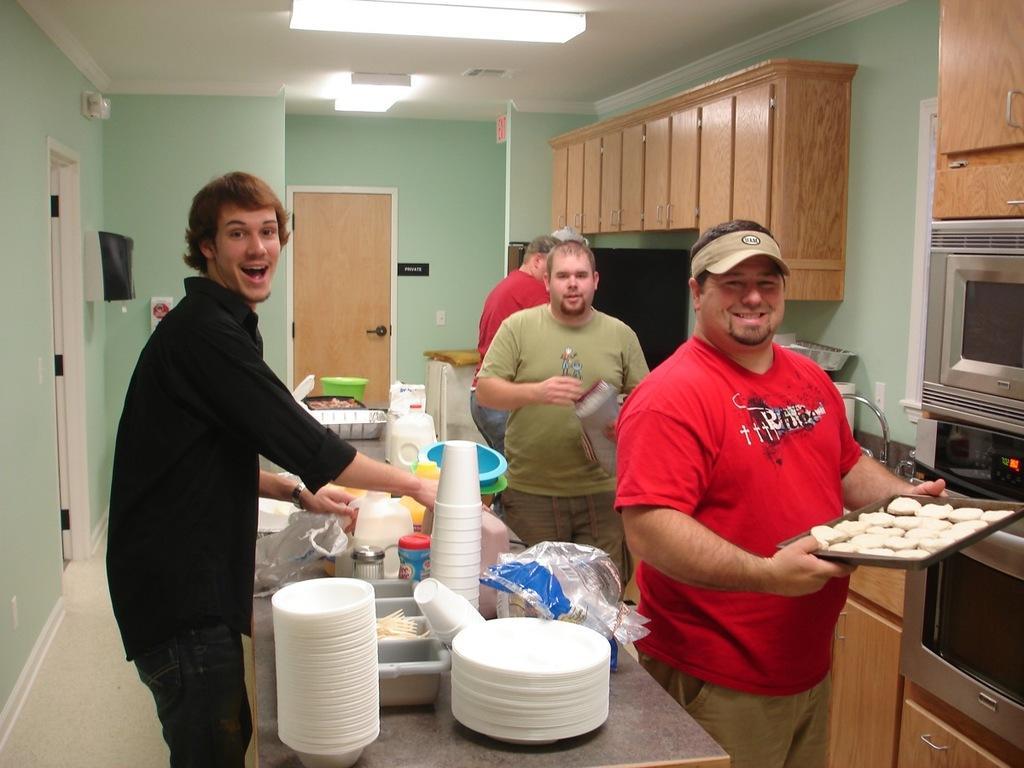Please provide a concise description of this image. In this image we can see people, table, plates, glasses, bowls, bottles, baskets, plastic covers, and few objects. There is a person holding a tray with food items. Here we can see oven, cupboards, door, walls, floor, ceiling, lights, and objects. 